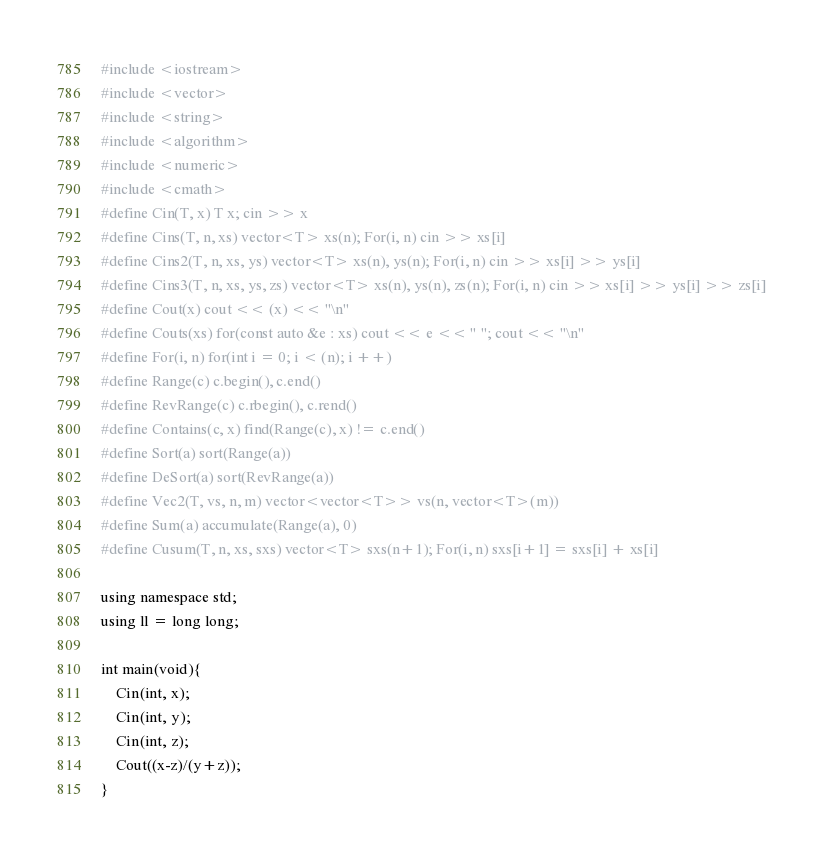Convert code to text. <code><loc_0><loc_0><loc_500><loc_500><_C++_>#include <iostream>
#include <vector>
#include <string>
#include <algorithm>
#include <numeric>
#include <cmath>
#define Cin(T, x) T x; cin >> x
#define Cins(T, n, xs) vector<T> xs(n); For(i, n) cin >> xs[i]
#define Cins2(T, n, xs, ys) vector<T> xs(n), ys(n); For(i, n) cin >> xs[i] >> ys[i]
#define Cins3(T, n, xs, ys, zs) vector<T> xs(n), ys(n), zs(n); For(i, n) cin >> xs[i] >> ys[i] >> zs[i]
#define Cout(x) cout << (x) << "\n"
#define Couts(xs) for(const auto &e : xs) cout << e << " "; cout << "\n"
#define For(i, n) for(int i = 0; i < (n); i ++)
#define Range(c) c.begin(), c.end()
#define RevRange(c) c.rbegin(), c.rend()
#define Contains(c, x) find(Range(c), x) != c.end()
#define Sort(a) sort(Range(a))
#define DeSort(a) sort(RevRange(a))
#define Vec2(T, vs, n, m) vector<vector<T>> vs(n, vector<T>(m))
#define Sum(a) accumulate(Range(a), 0)
#define Cusum(T, n, xs, sxs) vector<T> sxs(n+1); For(i, n) sxs[i+1] = sxs[i] + xs[i]

using namespace std;
using ll = long long;

int main(void){
    Cin(int, x);
    Cin(int, y);
    Cin(int, z);
    Cout((x-z)/(y+z));
}
</code> 